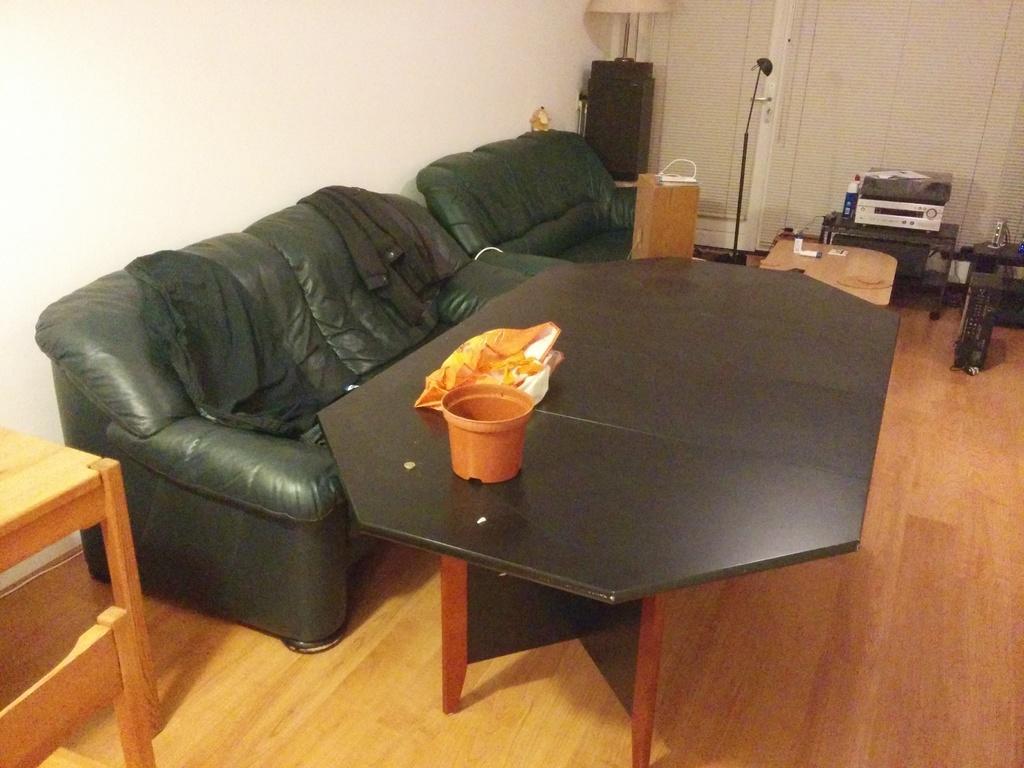Please provide a concise description of this image. In this image i can see a couch,table and some electronic products at the right side of the image. 